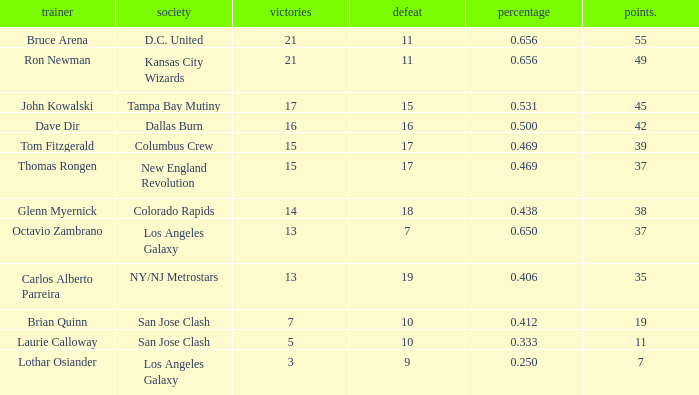What is the highest percent of Bruce Arena when he loses more than 11 games? None. 